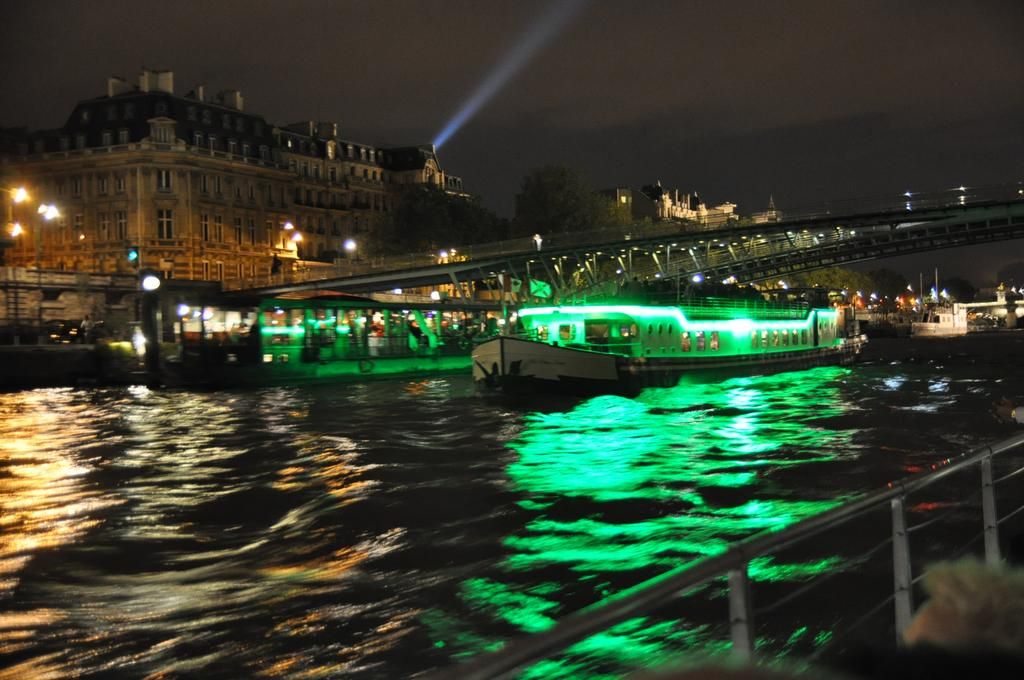What is in the water in the image? There are boats in the water in the image. What can be seen in the background of the image? There are buildings, street lights, a bridge, and the sky visible in the background. Can you describe the bridge in the background? The bridge is located in the background of the image. What is the profit margin of the boats in the image? There is no information about profit margins in the image, as it only shows boats in the water and various background elements. What channel is the boat navigating in the image? The image does not provide information about the specific channel or waterway where the boats are located. 